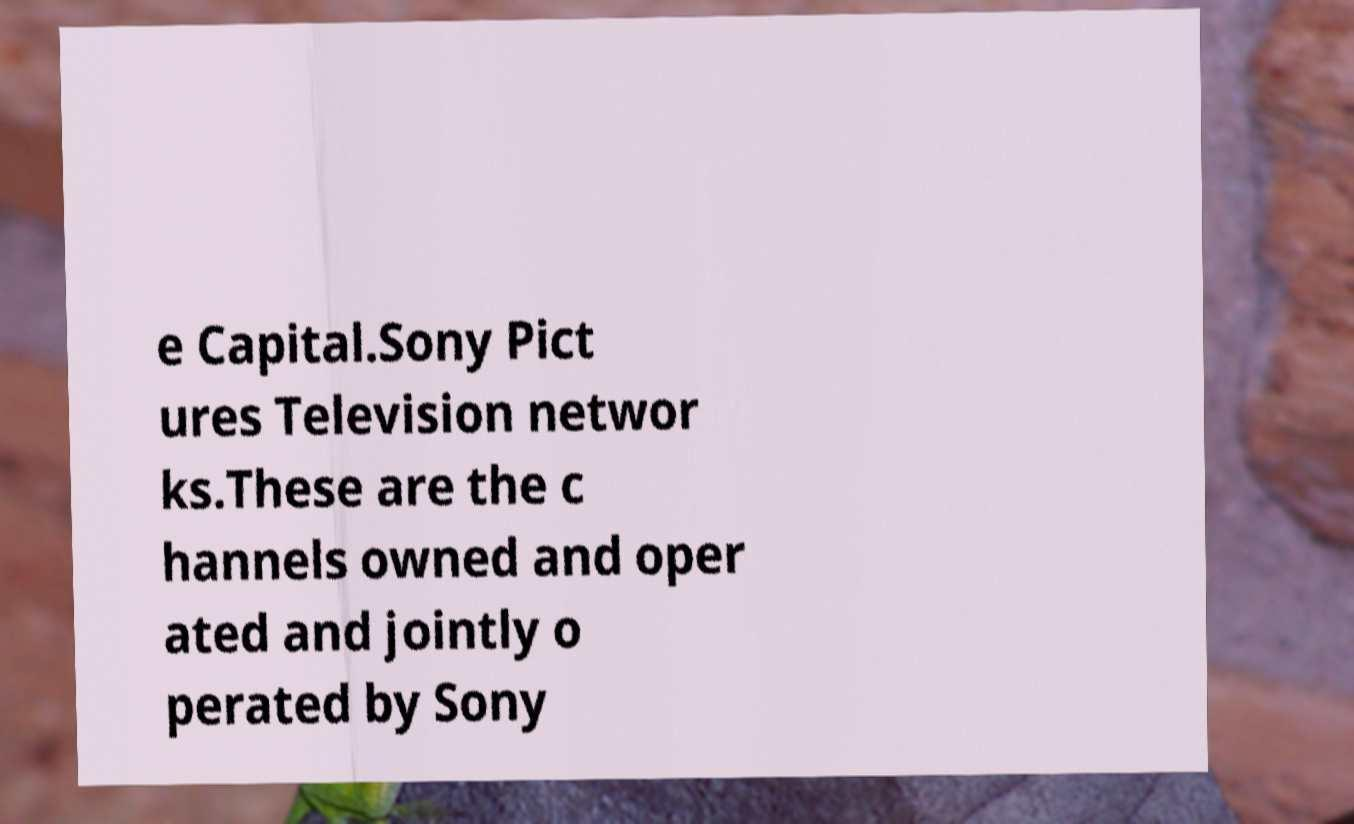Can you read and provide the text displayed in the image?This photo seems to have some interesting text. Can you extract and type it out for me? e Capital.Sony Pict ures Television networ ks.These are the c hannels owned and oper ated and jointly o perated by Sony 